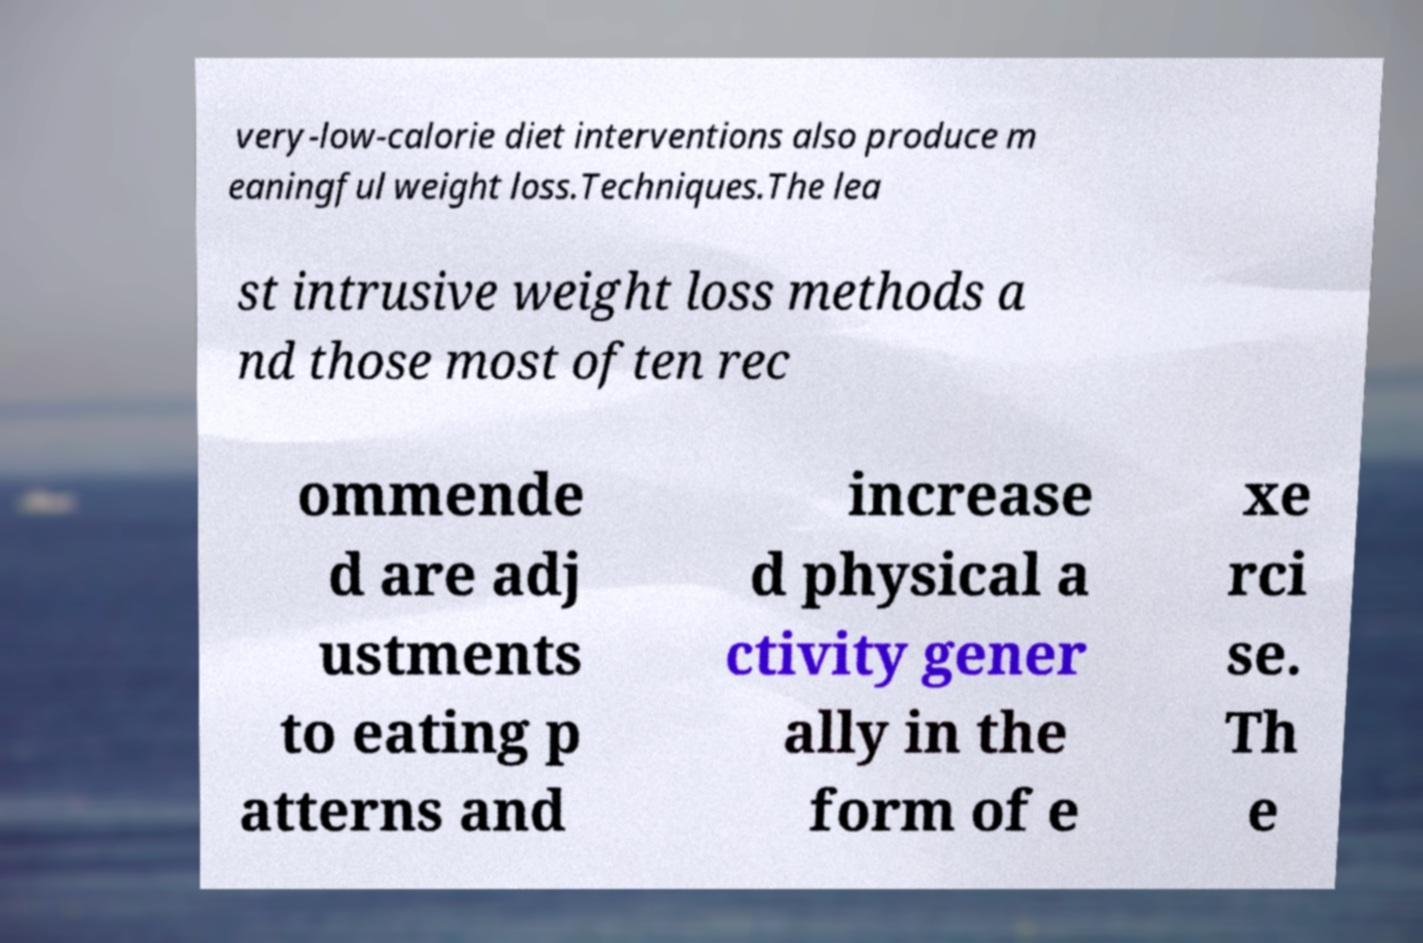I need the written content from this picture converted into text. Can you do that? very-low-calorie diet interventions also produce m eaningful weight loss.Techniques.The lea st intrusive weight loss methods a nd those most often rec ommende d are adj ustments to eating p atterns and increase d physical a ctivity gener ally in the form of e xe rci se. Th e 